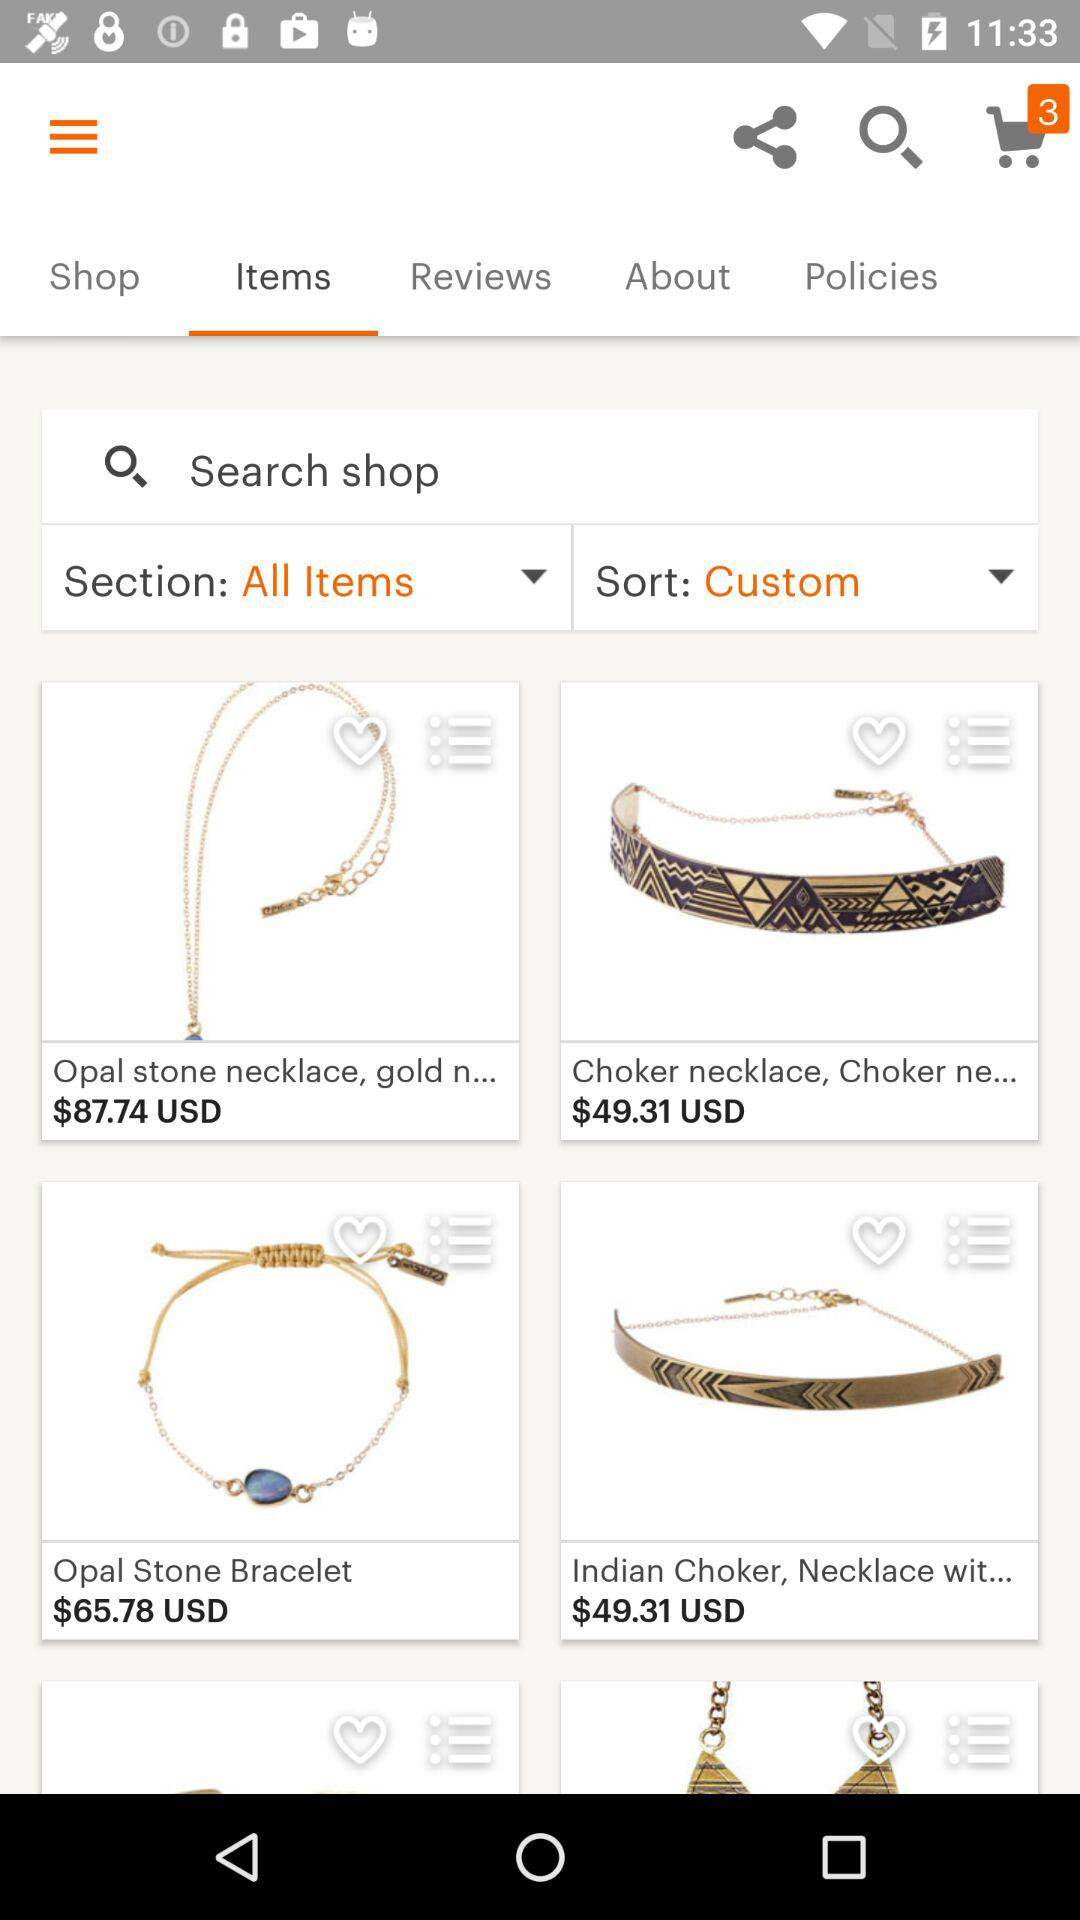What is the price for the Opal stone necklace? The price is $87.74 USD. 